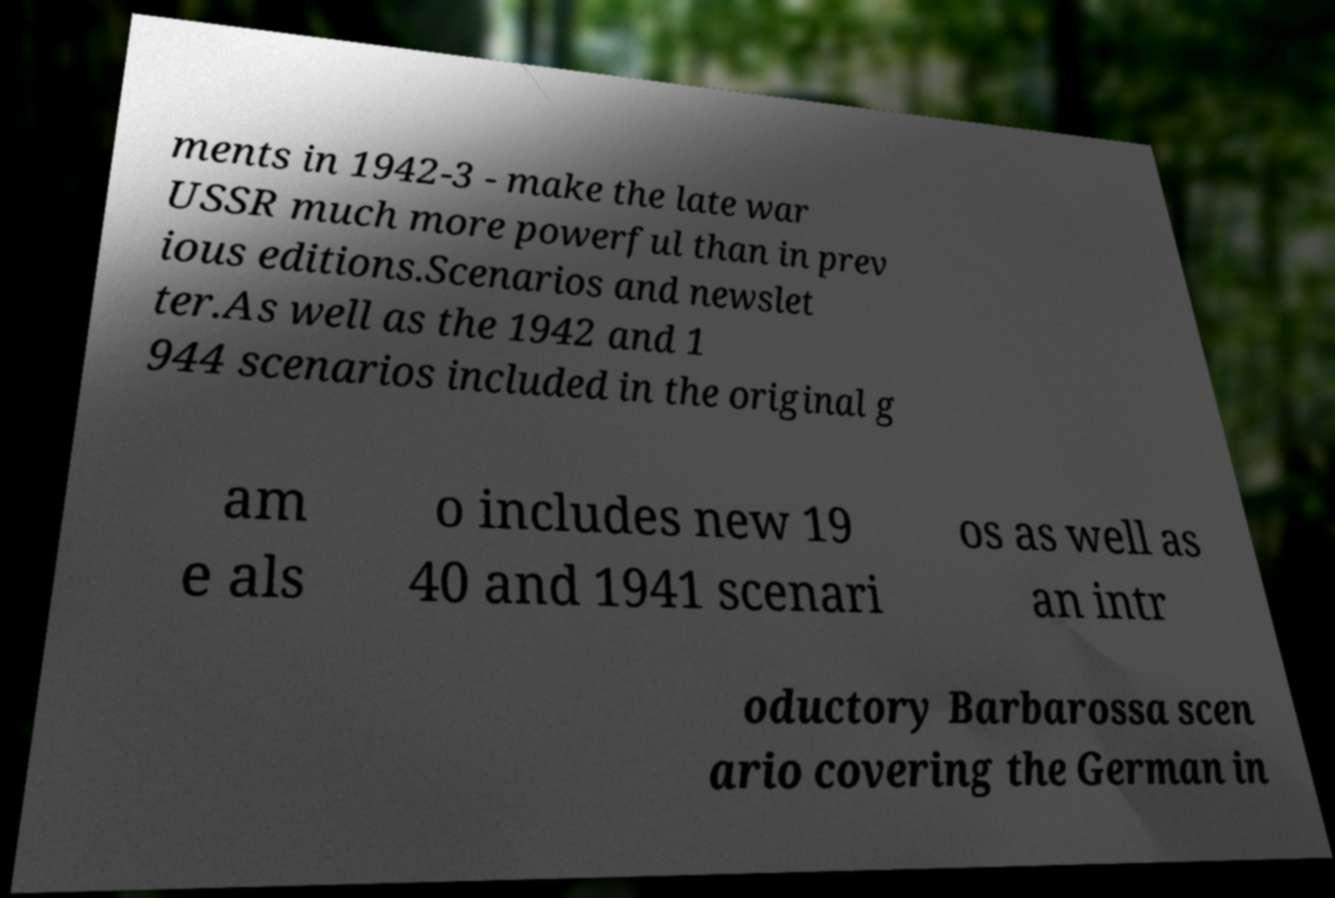Please identify and transcribe the text found in this image. ments in 1942-3 - make the late war USSR much more powerful than in prev ious editions.Scenarios and newslet ter.As well as the 1942 and 1 944 scenarios included in the original g am e als o includes new 19 40 and 1941 scenari os as well as an intr oductory Barbarossa scen ario covering the German in 